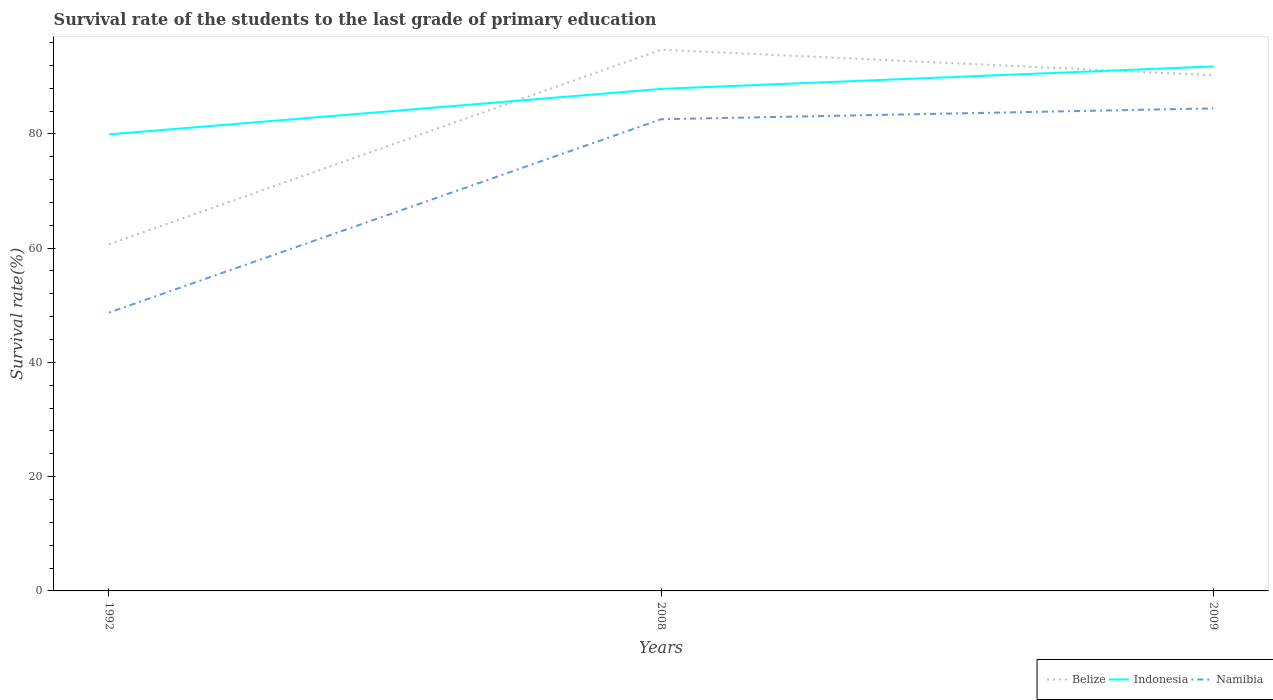Is the number of lines equal to the number of legend labels?
Ensure brevity in your answer.  Yes. Across all years, what is the maximum survival rate of the students in Indonesia?
Your answer should be compact. 79.91. What is the total survival rate of the students in Belize in the graph?
Provide a succinct answer. 4.46. What is the difference between the highest and the second highest survival rate of the students in Namibia?
Make the answer very short. 35.75. What is the difference between two consecutive major ticks on the Y-axis?
Make the answer very short. 20. Are the values on the major ticks of Y-axis written in scientific E-notation?
Offer a very short reply. No. Does the graph contain grids?
Provide a succinct answer. No. How are the legend labels stacked?
Provide a short and direct response. Horizontal. What is the title of the graph?
Provide a succinct answer. Survival rate of the students to the last grade of primary education. What is the label or title of the Y-axis?
Give a very brief answer. Survival rate(%). What is the Survival rate(%) in Belize in 1992?
Make the answer very short. 60.66. What is the Survival rate(%) of Indonesia in 1992?
Keep it short and to the point. 79.91. What is the Survival rate(%) in Namibia in 1992?
Provide a short and direct response. 48.71. What is the Survival rate(%) in Belize in 2008?
Your answer should be compact. 94.73. What is the Survival rate(%) of Indonesia in 2008?
Offer a terse response. 87.87. What is the Survival rate(%) of Namibia in 2008?
Provide a short and direct response. 82.56. What is the Survival rate(%) in Belize in 2009?
Ensure brevity in your answer.  90.27. What is the Survival rate(%) of Indonesia in 2009?
Your answer should be compact. 91.8. What is the Survival rate(%) in Namibia in 2009?
Ensure brevity in your answer.  84.46. Across all years, what is the maximum Survival rate(%) in Belize?
Your answer should be very brief. 94.73. Across all years, what is the maximum Survival rate(%) of Indonesia?
Ensure brevity in your answer.  91.8. Across all years, what is the maximum Survival rate(%) of Namibia?
Provide a succinct answer. 84.46. Across all years, what is the minimum Survival rate(%) in Belize?
Your answer should be compact. 60.66. Across all years, what is the minimum Survival rate(%) in Indonesia?
Ensure brevity in your answer.  79.91. Across all years, what is the minimum Survival rate(%) of Namibia?
Provide a short and direct response. 48.71. What is the total Survival rate(%) in Belize in the graph?
Keep it short and to the point. 245.66. What is the total Survival rate(%) of Indonesia in the graph?
Your answer should be very brief. 259.58. What is the total Survival rate(%) in Namibia in the graph?
Your answer should be compact. 215.74. What is the difference between the Survival rate(%) in Belize in 1992 and that in 2008?
Your answer should be very brief. -34.07. What is the difference between the Survival rate(%) of Indonesia in 1992 and that in 2008?
Give a very brief answer. -7.96. What is the difference between the Survival rate(%) of Namibia in 1992 and that in 2008?
Provide a succinct answer. -33.85. What is the difference between the Survival rate(%) of Belize in 1992 and that in 2009?
Your answer should be compact. -29.61. What is the difference between the Survival rate(%) of Indonesia in 1992 and that in 2009?
Provide a short and direct response. -11.89. What is the difference between the Survival rate(%) in Namibia in 1992 and that in 2009?
Keep it short and to the point. -35.75. What is the difference between the Survival rate(%) in Belize in 2008 and that in 2009?
Provide a succinct answer. 4.46. What is the difference between the Survival rate(%) in Indonesia in 2008 and that in 2009?
Ensure brevity in your answer.  -3.93. What is the difference between the Survival rate(%) in Namibia in 2008 and that in 2009?
Ensure brevity in your answer.  -1.9. What is the difference between the Survival rate(%) in Belize in 1992 and the Survival rate(%) in Indonesia in 2008?
Offer a terse response. -27.21. What is the difference between the Survival rate(%) in Belize in 1992 and the Survival rate(%) in Namibia in 2008?
Give a very brief answer. -21.9. What is the difference between the Survival rate(%) of Indonesia in 1992 and the Survival rate(%) of Namibia in 2008?
Make the answer very short. -2.66. What is the difference between the Survival rate(%) of Belize in 1992 and the Survival rate(%) of Indonesia in 2009?
Offer a very short reply. -31.14. What is the difference between the Survival rate(%) of Belize in 1992 and the Survival rate(%) of Namibia in 2009?
Provide a short and direct response. -23.8. What is the difference between the Survival rate(%) of Indonesia in 1992 and the Survival rate(%) of Namibia in 2009?
Your response must be concise. -4.56. What is the difference between the Survival rate(%) in Belize in 2008 and the Survival rate(%) in Indonesia in 2009?
Keep it short and to the point. 2.93. What is the difference between the Survival rate(%) in Belize in 2008 and the Survival rate(%) in Namibia in 2009?
Offer a very short reply. 10.27. What is the difference between the Survival rate(%) of Indonesia in 2008 and the Survival rate(%) of Namibia in 2009?
Give a very brief answer. 3.41. What is the average Survival rate(%) in Belize per year?
Your answer should be very brief. 81.89. What is the average Survival rate(%) of Indonesia per year?
Give a very brief answer. 86.53. What is the average Survival rate(%) in Namibia per year?
Your answer should be compact. 71.91. In the year 1992, what is the difference between the Survival rate(%) in Belize and Survival rate(%) in Indonesia?
Provide a succinct answer. -19.25. In the year 1992, what is the difference between the Survival rate(%) of Belize and Survival rate(%) of Namibia?
Your response must be concise. 11.95. In the year 1992, what is the difference between the Survival rate(%) of Indonesia and Survival rate(%) of Namibia?
Your answer should be compact. 31.19. In the year 2008, what is the difference between the Survival rate(%) of Belize and Survival rate(%) of Indonesia?
Your answer should be compact. 6.86. In the year 2008, what is the difference between the Survival rate(%) in Belize and Survival rate(%) in Namibia?
Your response must be concise. 12.17. In the year 2008, what is the difference between the Survival rate(%) in Indonesia and Survival rate(%) in Namibia?
Ensure brevity in your answer.  5.31. In the year 2009, what is the difference between the Survival rate(%) in Belize and Survival rate(%) in Indonesia?
Your answer should be very brief. -1.53. In the year 2009, what is the difference between the Survival rate(%) of Belize and Survival rate(%) of Namibia?
Give a very brief answer. 5.8. In the year 2009, what is the difference between the Survival rate(%) of Indonesia and Survival rate(%) of Namibia?
Offer a very short reply. 7.34. What is the ratio of the Survival rate(%) of Belize in 1992 to that in 2008?
Provide a succinct answer. 0.64. What is the ratio of the Survival rate(%) of Indonesia in 1992 to that in 2008?
Make the answer very short. 0.91. What is the ratio of the Survival rate(%) in Namibia in 1992 to that in 2008?
Provide a short and direct response. 0.59. What is the ratio of the Survival rate(%) of Belize in 1992 to that in 2009?
Your answer should be compact. 0.67. What is the ratio of the Survival rate(%) of Indonesia in 1992 to that in 2009?
Give a very brief answer. 0.87. What is the ratio of the Survival rate(%) of Namibia in 1992 to that in 2009?
Offer a terse response. 0.58. What is the ratio of the Survival rate(%) in Belize in 2008 to that in 2009?
Offer a terse response. 1.05. What is the ratio of the Survival rate(%) in Indonesia in 2008 to that in 2009?
Make the answer very short. 0.96. What is the ratio of the Survival rate(%) in Namibia in 2008 to that in 2009?
Your answer should be very brief. 0.98. What is the difference between the highest and the second highest Survival rate(%) in Belize?
Your answer should be very brief. 4.46. What is the difference between the highest and the second highest Survival rate(%) of Indonesia?
Your answer should be compact. 3.93. What is the difference between the highest and the second highest Survival rate(%) of Namibia?
Ensure brevity in your answer.  1.9. What is the difference between the highest and the lowest Survival rate(%) of Belize?
Ensure brevity in your answer.  34.07. What is the difference between the highest and the lowest Survival rate(%) of Indonesia?
Give a very brief answer. 11.89. What is the difference between the highest and the lowest Survival rate(%) of Namibia?
Keep it short and to the point. 35.75. 